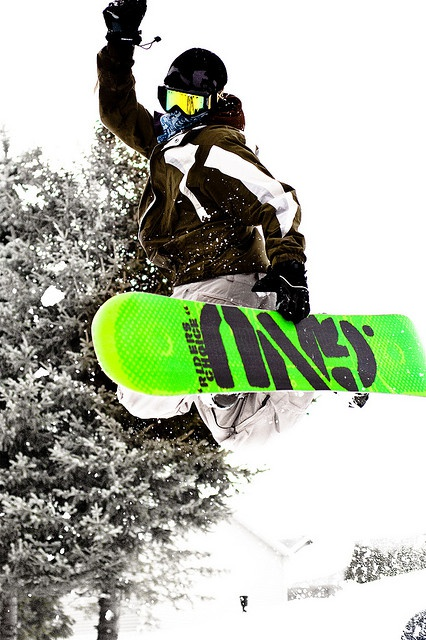Describe the objects in this image and their specific colors. I can see people in white, black, darkgray, and gray tones and snowboard in white, lime, and black tones in this image. 